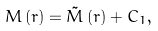Convert formula to latex. <formula><loc_0><loc_0><loc_500><loc_500>M \left ( r \right ) = \tilde { M } \left ( r \right ) + C _ { 1 } ,</formula> 